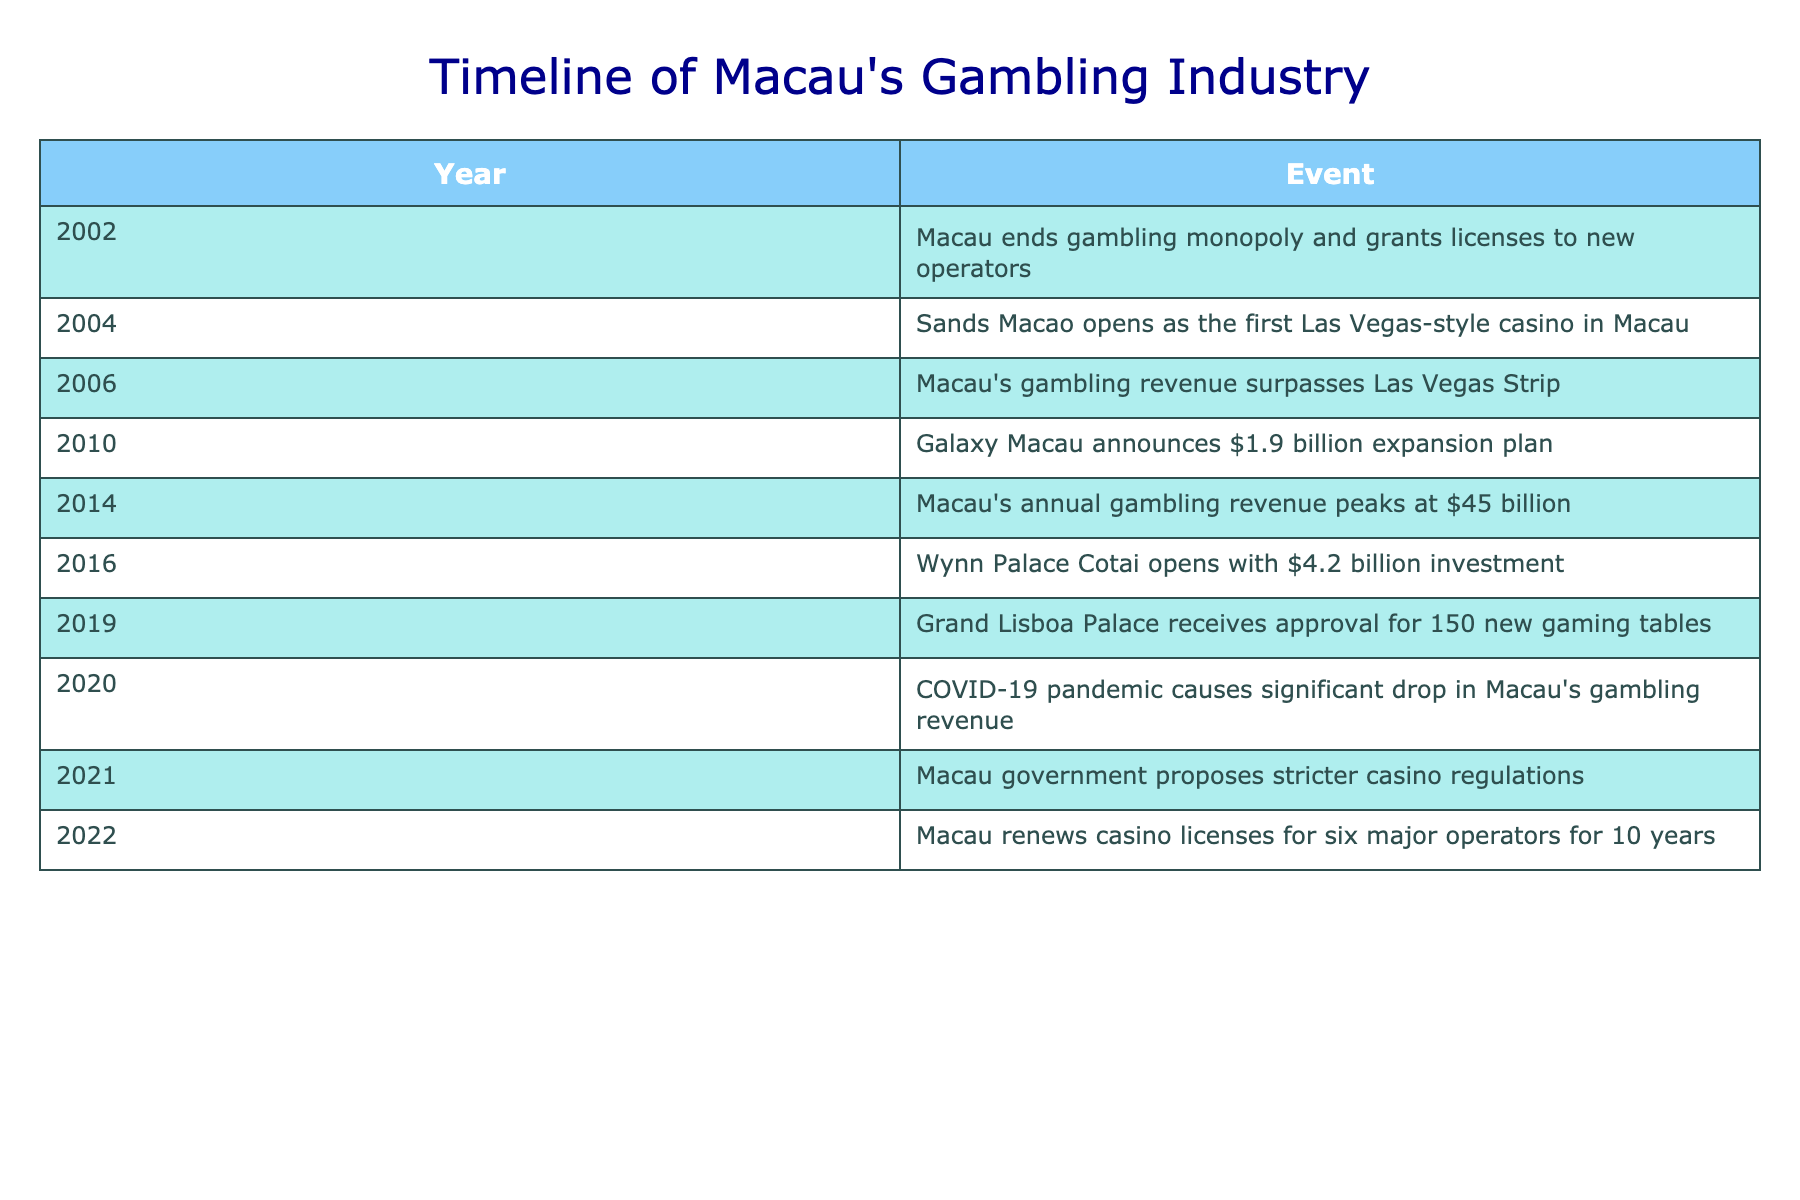What year did Macau end its gambling monopoly? The table shows that Macau ended its gambling monopoly in the year 2002.
Answer: 2002 Which casino opened as the first Las Vegas-style casino in Macau? According to the table, Sands Macao opened as the first Las Vegas-style casino in Macau in 2004.
Answer: Sands Macao What was the peak annual gambling revenue in Macau? The highest annual gambling revenue recorded in the table is 45 billion dollars in 2014.
Answer: 45 billion How many years passed between Macau's monopoly ending and when its gambling revenue surpassed that of Las Vegas? The gambling monopoly ended in 2002 and Macau's gambling revenue surpassed that of Las Vegas in 2006; thus, it was 4 years in total (2006 - 2002).
Answer: 4 years Did the COVID-19 pandemic cause an increase in Macau's gambling revenue? Based on the table, it is clear that the COVID-19 pandemic in 2020 caused a significant drop in Macau's gambling revenue, indicating that the answer is no.
Answer: No What was the investment amount for Wynn Palace Cotai when it opened? From the table, the investment amount for Wynn Palace Cotai, which opened in 2016, was 4.2 billion dollars.
Answer: 4.2 billion Was the gambling revenue in Macau higher or lower in 2021 compared to the peak in 2014? The table indicates that the peak revenue in 2014 was 45 billion dollars while the revenue was significantly lower in 2021 due to proposals for stricter regulations. Therefore, the answer is lower.
Answer: Lower What is the total number of new gaming tables approved for Grand Lisboa Palace in 2019 compared to the peak annual revenue in 2014? The total number of new gaming tables approved for Grand Lisboa Palace in 2019 was 150, while the peak annual gambling revenue in 2014 was 45 billion dollars. The comparison does not require math but indicates a significant difference in scale, revealing the varying nature of the two figures.
Answer: 150 tables; 45 billion revenue In what year did Macau renew casino licenses for major operators? The table states that Macau renewed casino licenses for six major operators in 2022.
Answer: 2022 